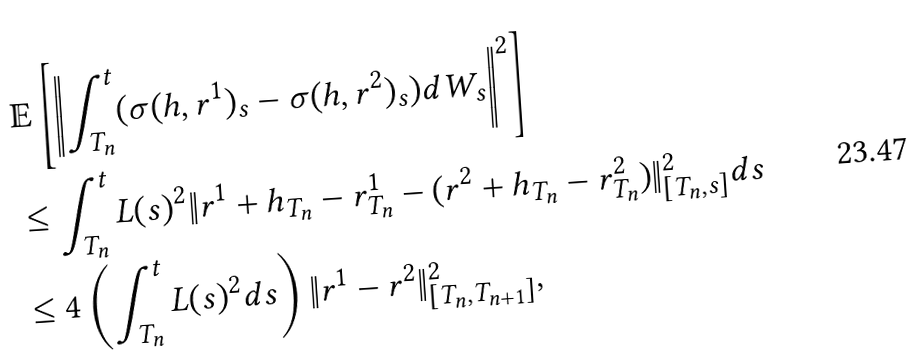Convert formula to latex. <formula><loc_0><loc_0><loc_500><loc_500>& \mathbb { E } \left [ \left \| \int _ { T _ { n } } ^ { t } ( \sigma ( h , r ^ { 1 } ) _ { s } - \sigma ( h , r ^ { 2 } ) _ { s } ) d W _ { s } \right \| ^ { 2 } \right ] \\ & \leq \int _ { T _ { n } } ^ { t } L ( s ) ^ { 2 } \| r ^ { 1 } + h _ { T _ { n } } - r _ { T _ { n } } ^ { 1 } - ( r ^ { 2 } + h _ { T _ { n } } - r _ { T _ { n } } ^ { 2 } ) \| _ { [ T _ { n } , s ] } ^ { 2 } d s \\ & \leq 4 \left ( \int _ { T _ { n } } ^ { t } L ( s ) ^ { 2 } d s \right ) \| r ^ { 1 } - r ^ { 2 } \| _ { [ T _ { n } , T _ { n + 1 } ] } ^ { 2 } ,</formula> 